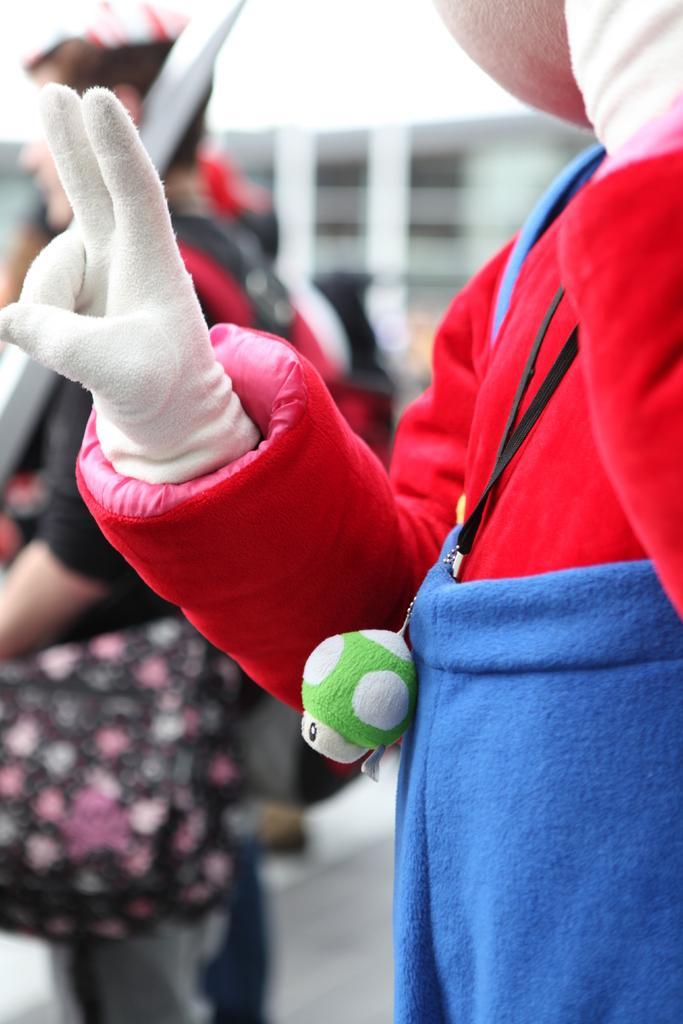Can you describe this image briefly? In this image, we can see persons wearing clothes. In the background, image is blurred. 